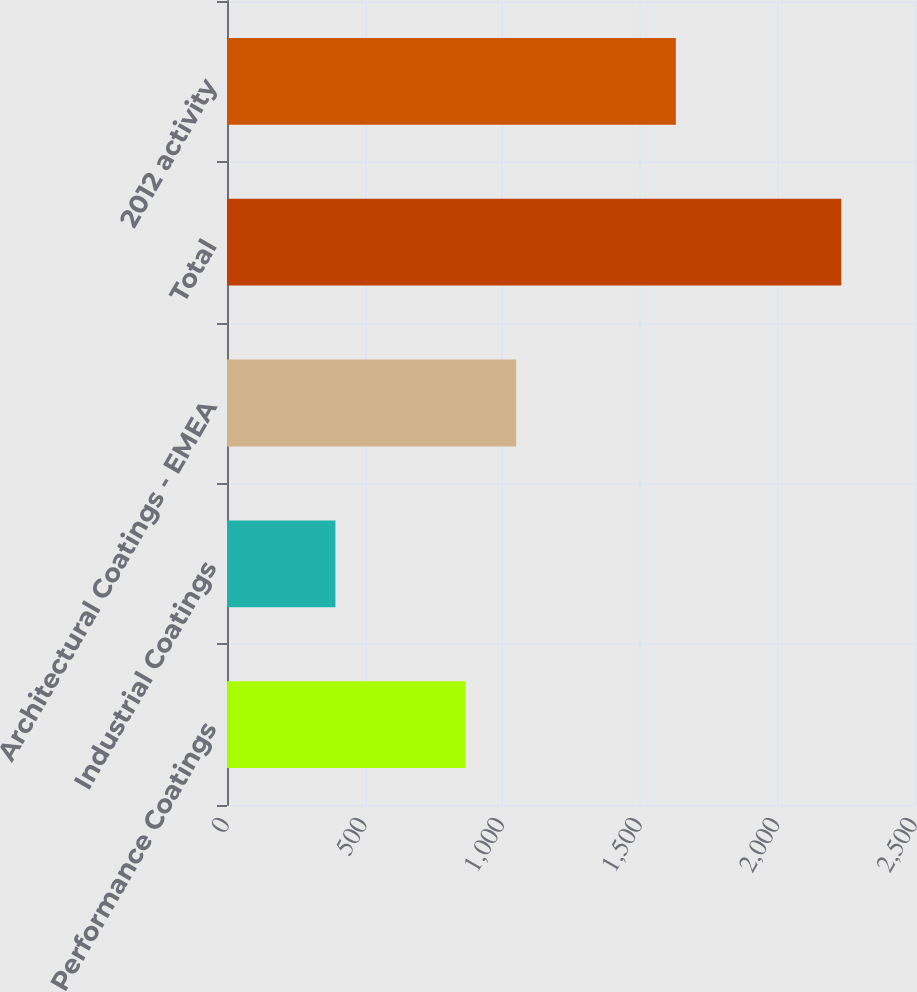Convert chart to OTSL. <chart><loc_0><loc_0><loc_500><loc_500><bar_chart><fcel>Performance Coatings<fcel>Industrial Coatings<fcel>Architectural Coatings - EMEA<fcel>Total<fcel>2012 activity<nl><fcel>867<fcel>394<fcel>1050.8<fcel>2232<fcel>1631<nl></chart> 